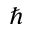<formula> <loc_0><loc_0><loc_500><loc_500>\hbar</formula> 